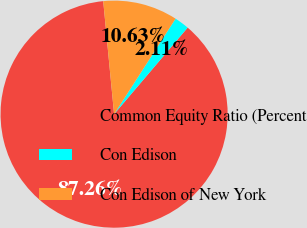Convert chart. <chart><loc_0><loc_0><loc_500><loc_500><pie_chart><fcel>Common Equity Ratio (Percent<fcel>Con Edison<fcel>Con Edison of New York<nl><fcel>87.26%<fcel>2.11%<fcel>10.63%<nl></chart> 